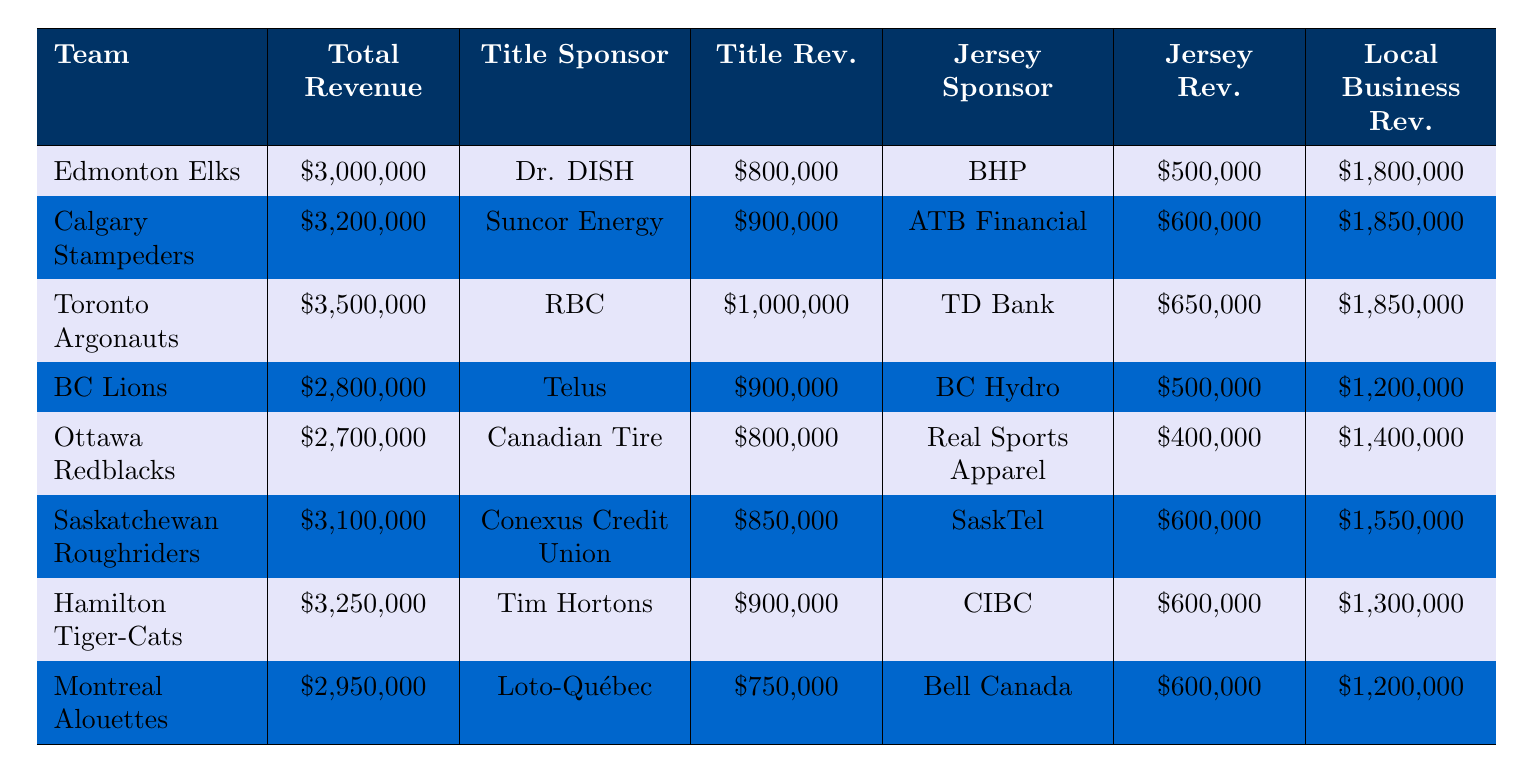What is the total sponsorship revenue for the Toronto Argonauts? The table shows that the total sponsorship revenue for the Toronto Argonauts is recorded as $3,500,000.
Answer: $3,500,000 Which team has the highest title sponsorship revenue? By comparing the title sponsorship revenue of each team, the Toronto Argonauts have the highest at $1,000,000.
Answer: Toronto Argonauts What is the total revenue contributed by local business sponsorships for the BC Lions? The table indicates that the local business sponsorships for the BC Lions amount to $1,200,000.
Answer: $1,200,000 Calculate the average jersey sponsorship revenue across all teams. The jersey sponsorship revenues are: $500,000 + $600,000 + $650,000 + $500,000 + $400,000 + $600,000 + $600,000 + $600,000 = $4,950,000. There are 8 teams, so the average is $4,950,000 / 8 = $618,750.
Answer: $618,750 Does Hamilton Tiger-Cats have more total sponsorship revenue than Ottawa Redblacks? The total sponsorship revenue for Hamilton Tiger-Cats is $3,250,000, while for Ottawa Redblacks, it is $2,700,000. Therefore, Hamilton Tiger-Cats have more revenue.
Answer: Yes What is the difference in total sponsorship revenue between the highest and lowest earning teams? The highest total sponsorship revenue is from Toronto Argonauts at $3,500,000, and the lowest is from Ottawa Redblacks at $2,700,000. The difference is $3,500,000 - $2,700,000 = $800,000.
Answer: $800,000 Which team has the highest local business sponsorship revenue? By reviewing the local business sponsorship revenues, the Edmonton Elks have the highest at $1,800,000.
Answer: Edmonton Elks What percentage of the total sponsorship revenue for the Saskatchewan Roughriders comes from title sponsorship? The title sponsorship revenue for the Saskatchewan Roughriders is $850,000, and their total sponsorship revenue is $3,100,000. The percentage is ($850,000 / $3,100,000) * 100 = 27.42%.
Answer: 27.42% Is the combined title and jersey sponsorship revenue for the Calgary Stampeders greater than their local business sponsorship revenue? The combined title and jersey sponsorship revenue for Calgary Stampeders is $900,000 + $600,000 = $1,500,000, which is less than their local business sponsorship revenue of $1,850,000.
Answer: No What is the total value of all title sponsorships combined for all teams? Adding the title sponsorship revenues: $800,000 + $900,000 + $1,000,000 + $900,000 + $800,000 + $850,000 + $900,000 + $750,000 = $5,100,000.
Answer: $5,100,000 